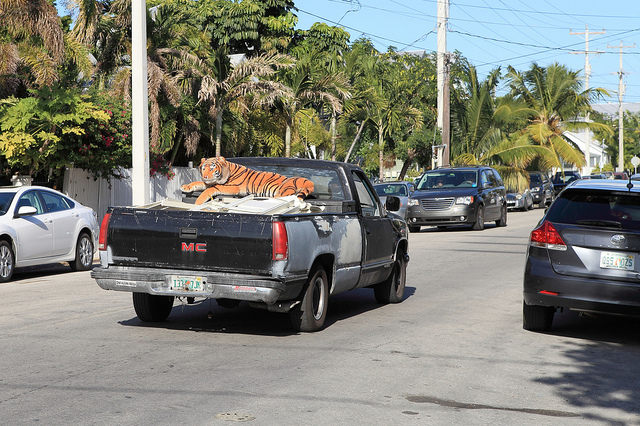Please transcribe the text in this image. MC 